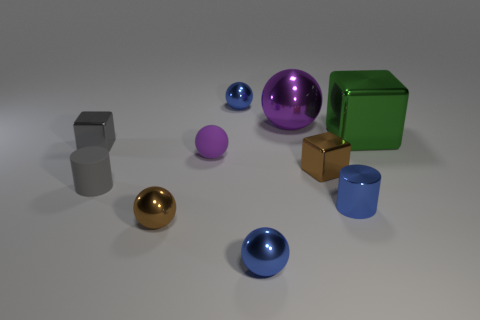There is a brown metal object behind the small brown shiny sphere; is its shape the same as the big shiny object that is behind the green thing?
Your answer should be compact. No. What is the shape of the purple rubber thing that is the same size as the blue cylinder?
Offer a terse response. Sphere. What number of matte things are either purple cylinders or big objects?
Your response must be concise. 0. Are the small object behind the green cube and the small cylinder left of the tiny brown metallic ball made of the same material?
Your answer should be very brief. No. There is a cylinder that is made of the same material as the green block; what color is it?
Provide a succinct answer. Blue. Are there more large things that are to the left of the small blue cylinder than big green objects that are left of the big sphere?
Make the answer very short. Yes. Are any large yellow shiny blocks visible?
Provide a succinct answer. No. There is a thing that is the same color as the large shiny ball; what is its material?
Ensure brevity in your answer.  Rubber. How many objects are tiny gray metal things or brown shiny objects?
Provide a succinct answer. 3. Are there any small cubes of the same color as the metallic cylinder?
Provide a succinct answer. No. 